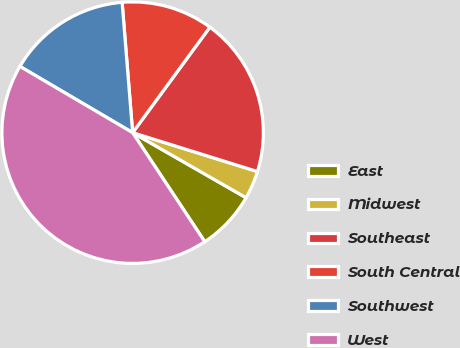Convert chart. <chart><loc_0><loc_0><loc_500><loc_500><pie_chart><fcel>East<fcel>Midwest<fcel>Southeast<fcel>South Central<fcel>Southwest<fcel>West<nl><fcel>7.41%<fcel>3.48%<fcel>19.75%<fcel>11.34%<fcel>15.26%<fcel>42.76%<nl></chart> 